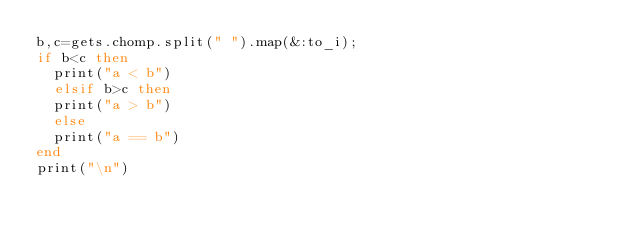<code> <loc_0><loc_0><loc_500><loc_500><_Ruby_>b,c=gets.chomp.split(" ").map(&:to_i);
if b<c then
  print("a < b")
  elsif b>c then
  print("a > b")
  else 
  print("a == b")
end
print("\n")</code> 